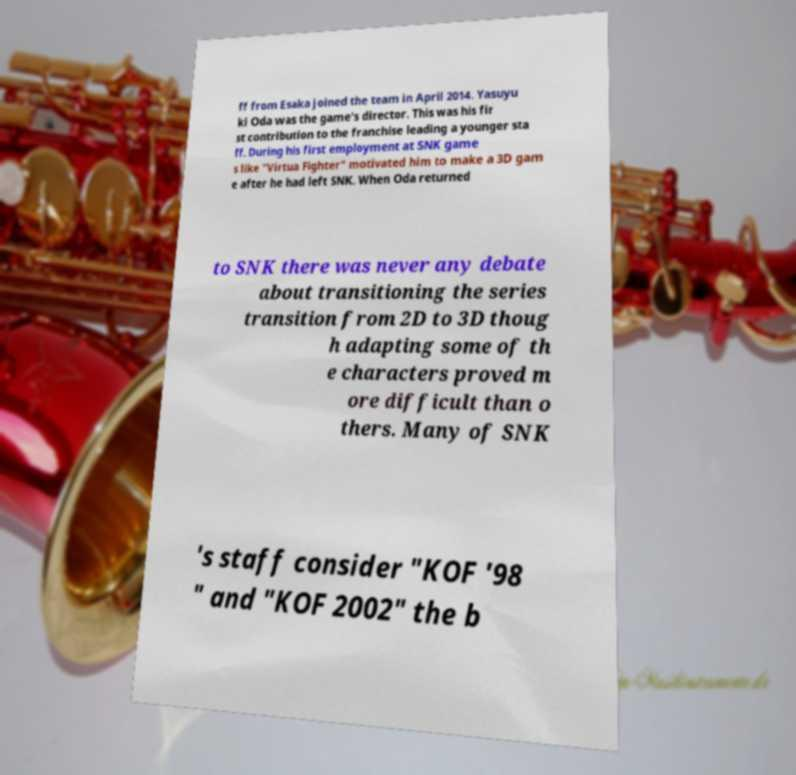I need the written content from this picture converted into text. Can you do that? ff from Esaka joined the team in April 2014. Yasuyu ki Oda was the game's director. This was his fir st contribution to the franchise leading a younger sta ff. During his first employment at SNK game s like "Virtua Fighter" motivated him to make a 3D gam e after he had left SNK. When Oda returned to SNK there was never any debate about transitioning the series transition from 2D to 3D thoug h adapting some of th e characters proved m ore difficult than o thers. Many of SNK 's staff consider "KOF '98 " and "KOF 2002" the b 